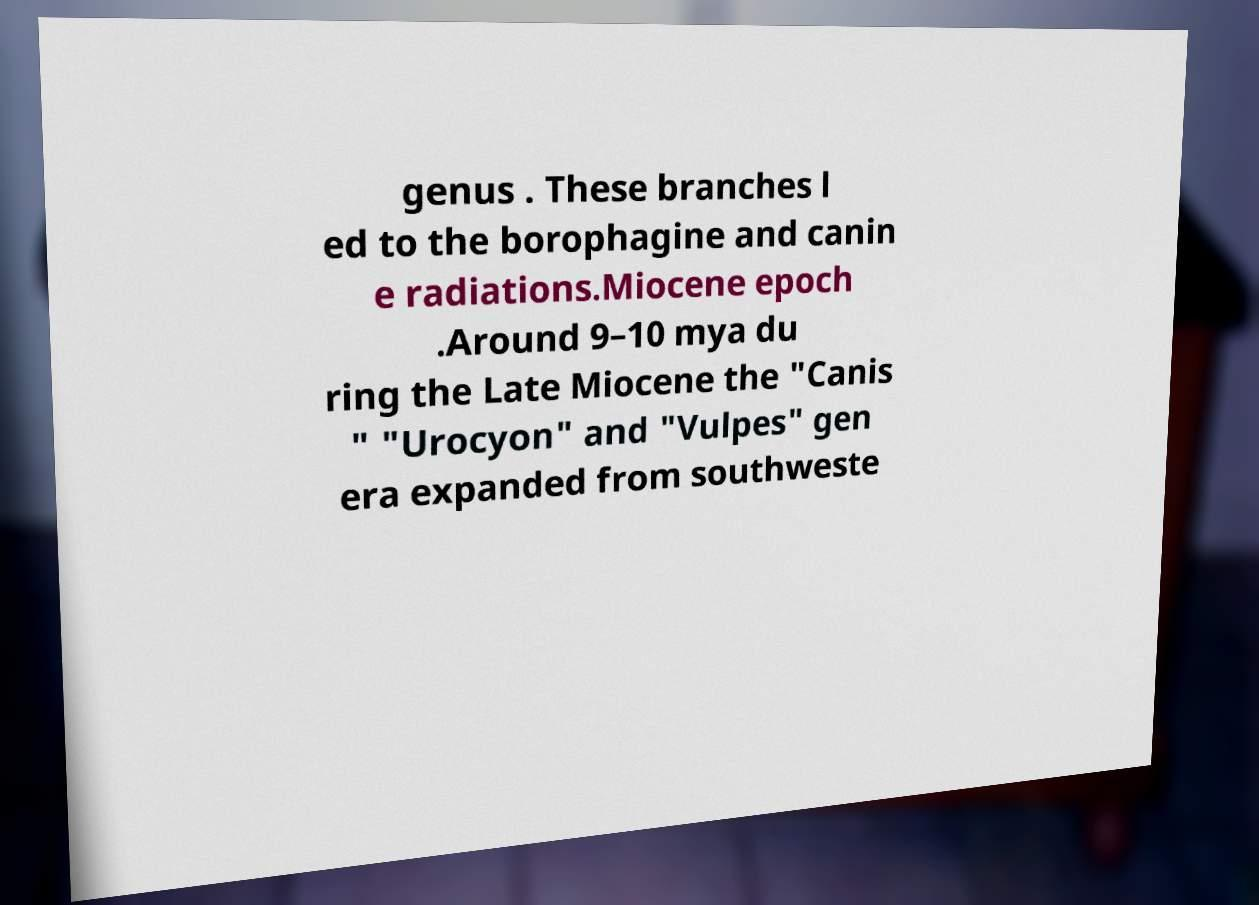Can you accurately transcribe the text from the provided image for me? genus . These branches l ed to the borophagine and canin e radiations.Miocene epoch .Around 9–10 mya du ring the Late Miocene the "Canis " "Urocyon" and "Vulpes" gen era expanded from southweste 